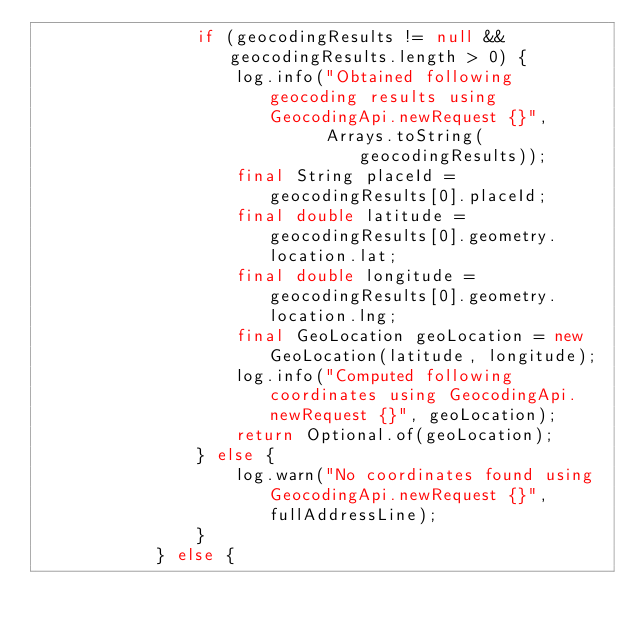<code> <loc_0><loc_0><loc_500><loc_500><_Java_>                if (geocodingResults != null && geocodingResults.length > 0) {
                    log.info("Obtained following geocoding results using GeocodingApi.newRequest {}",
                             Arrays.toString(geocodingResults));
                    final String placeId = geocodingResults[0].placeId;
                    final double latitude = geocodingResults[0].geometry.location.lat;
                    final double longitude = geocodingResults[0].geometry.location.lng;
                    final GeoLocation geoLocation = new GeoLocation(latitude, longitude);
                    log.info("Computed following coordinates using GeocodingApi.newRequest {}", geoLocation);
                    return Optional.of(geoLocation);
                } else {
                    log.warn("No coordinates found using GeocodingApi.newRequest {}", fullAddressLine);
                }
            } else {</code> 